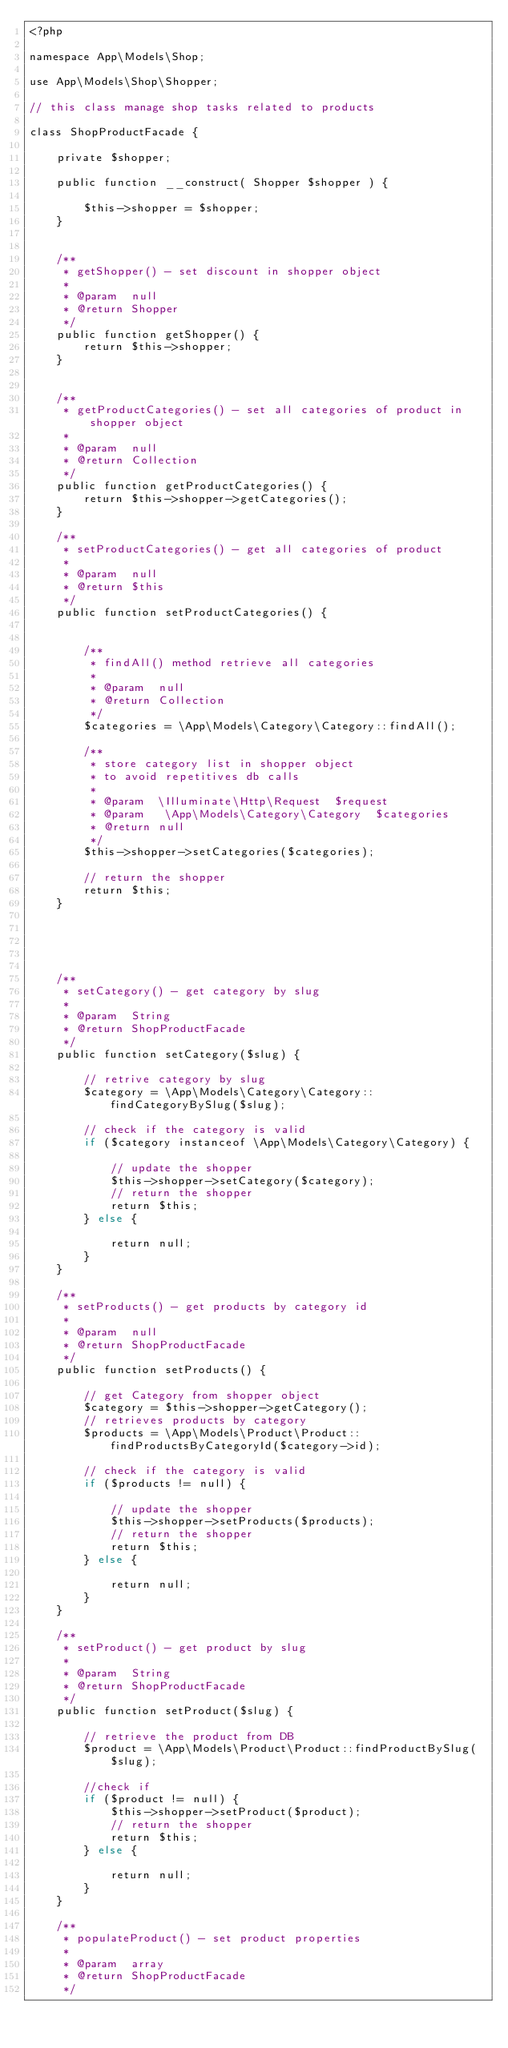<code> <loc_0><loc_0><loc_500><loc_500><_PHP_><?php

namespace App\Models\Shop;

use App\Models\Shop\Shopper;

// this class manage shop tasks related to products

class ShopProductFacade {

    private $shopper;

    public function __construct( Shopper $shopper ) {

        $this->shopper = $shopper;
    }
    
    
    /**
     * getShopper() - set discount in shopper object
     *
     * @param  null
     * @return Shopper
     */
    public function getShopper() {
        return $this->shopper;
    }

   
    /**
     * getProductCategories() - set all categories of product in shopper object
     *
     * @param  null
     * @return Collection
     */
    public function getProductCategories() {
        return $this->shopper->getCategories();
    }

    /**
     * setProductCategories() - get all categories of product
     *
     * @param  null
     * @return $this
     */
    public function setProductCategories() {


        /**
         * findAll() method retrieve all categories
         *
         * @param  null
         * @return Collection
         */
        $categories = \App\Models\Category\Category::findAll();

        /**
         * store category list in shopper object
         * to avoid repetitives db calls
         *
         * @param  \Illuminate\Http\Request  $request
         * @param   \App\Models\Category\Category  $categories
         * @return null
         */
        $this->shopper->setCategories($categories);

        // return the shopper
        return $this;
    }

    

   

    /**
     * setCategory() - get category by slug
     *
     * @param  String
     * @return ShopProductFacade
     */
    public function setCategory($slug) {

        // retrive category by slug
        $category = \App\Models\Category\Category::findCategoryBySlug($slug);

        // check if the category is valid
        if ($category instanceof \App\Models\Category\Category) {

            // update the shopper
            $this->shopper->setCategory($category);
            // return the shopper
            return $this;
        } else {

            return null;
        }
    }

    /**
     * setProducts() - get products by category id 
     *
     * @param  null
     * @return ShopProductFacade
     */
    public function setProducts() {

        // get Category from shopper object
        $category = $this->shopper->getCategory();
        // retrieves products by category 
        $products = \App\Models\Product\Product::findProductsByCategoryId($category->id);

        // check if the category is valid
        if ($products != null) {

            // update the shopper
            $this->shopper->setProducts($products);
            // return the shopper
            return $this;
        } else {

            return null;
        }
    }

    /**
     * setProduct() - get product by slug
     *
     * @param  String
     * @return ShopProductFacade
     */
    public function setProduct($slug) {

        // retrieve the product from DB
        $product = \App\Models\Product\Product::findProductBySlug($slug);

        //check if
        if ($product != null) {
            $this->shopper->setProduct($product);
            // return the shopper
            return $this;
        } else {

            return null;
        }
    }

    /**
     * populateProduct() - set product properties
     *
     * @param  array
     * @return ShopProductFacade
     */</code> 